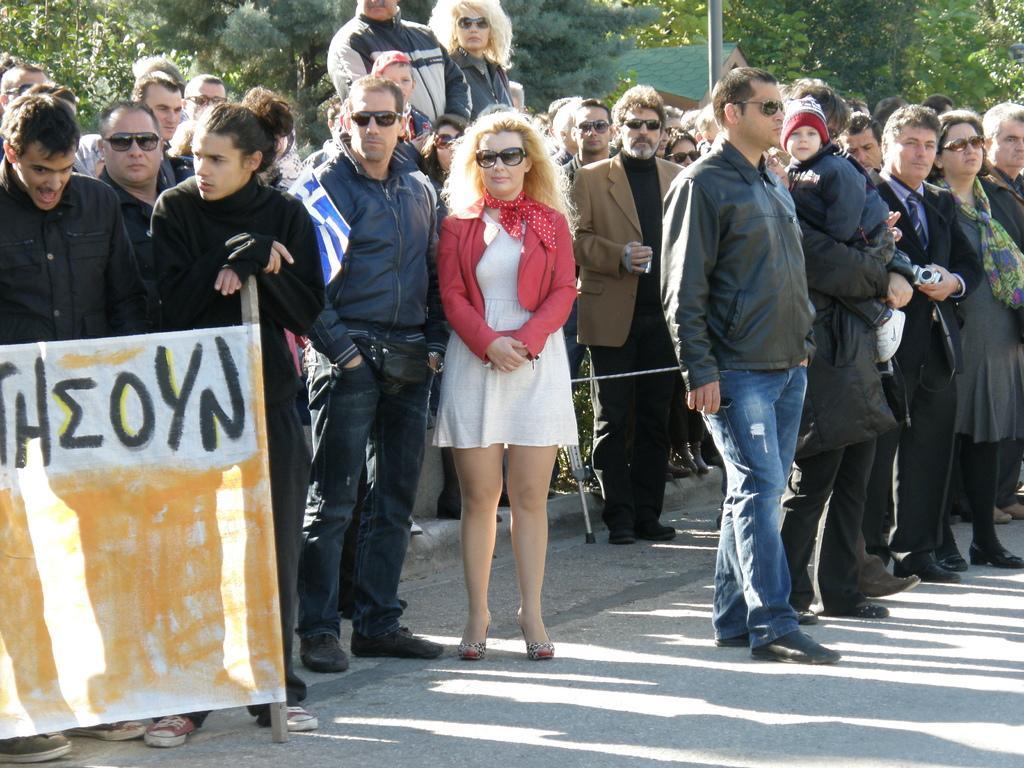Could you give a brief overview of what you see in this image? In the image we can see there are many people standing, they are wearing clothes and some of them are wearing goggles, this is a poster, footpath, trees, pole and house. 